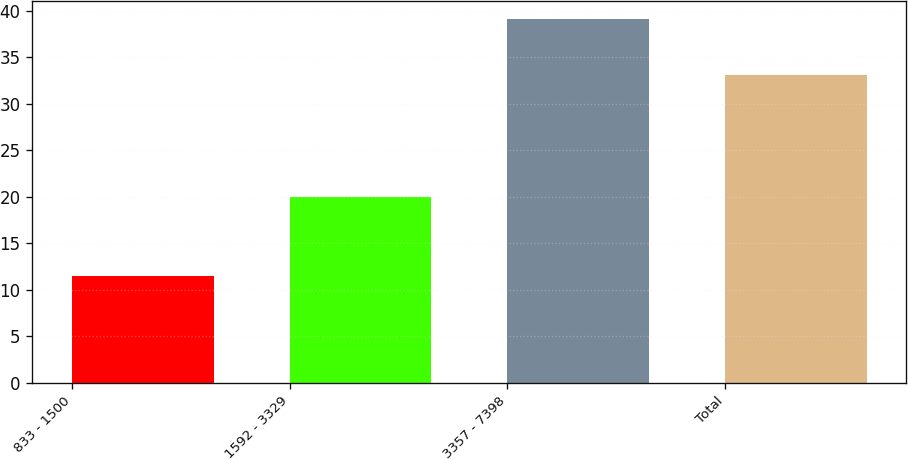Convert chart. <chart><loc_0><loc_0><loc_500><loc_500><bar_chart><fcel>833 - 1500<fcel>1592 - 3329<fcel>3357 - 7398<fcel>Total<nl><fcel>11.53<fcel>19.97<fcel>39.06<fcel>33.14<nl></chart> 